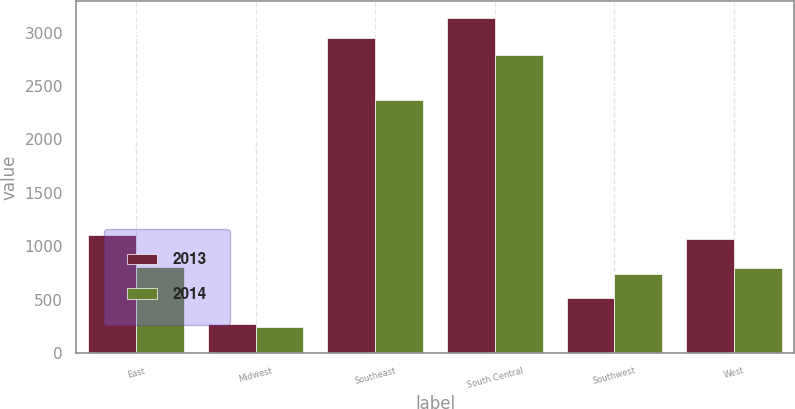Convert chart to OTSL. <chart><loc_0><loc_0><loc_500><loc_500><stacked_bar_chart><ecel><fcel>East<fcel>Midwest<fcel>Southeast<fcel>South Central<fcel>Southwest<fcel>West<nl><fcel>2013<fcel>1106<fcel>271<fcel>2955<fcel>3136<fcel>517<fcel>1072<nl><fcel>2014<fcel>807<fcel>248<fcel>2369<fcel>2794<fcel>738<fcel>795<nl></chart> 